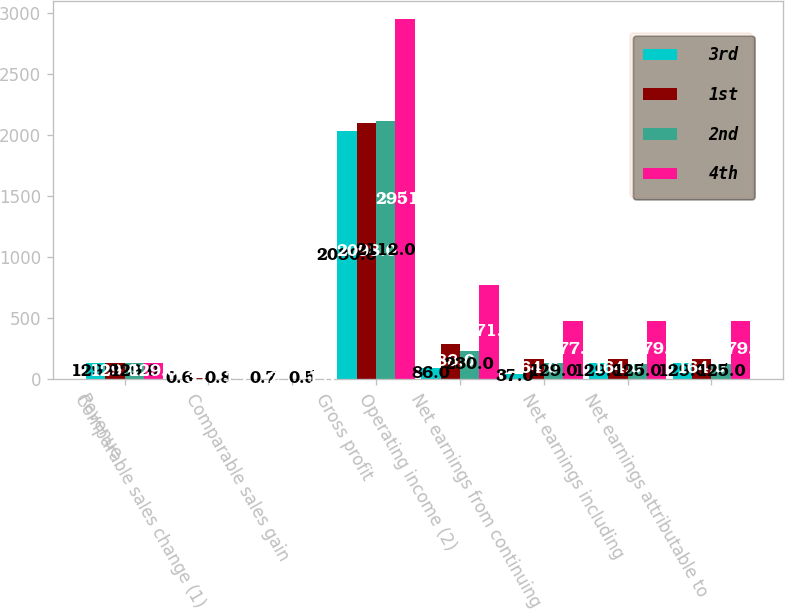Convert chart to OTSL. <chart><loc_0><loc_0><loc_500><loc_500><stacked_bar_chart><ecel><fcel>Revenue<fcel>Comparable sales change (1)<fcel>Comparable sales gain<fcel>Gross profit<fcel>Operating income (2)<fcel>Net earnings from continuing<fcel>Net earnings including<fcel>Net earnings attributable to<nl><fcel>3rd<fcel>129<fcel>0.6<fcel>0.7<fcel>2030<fcel>86<fcel>37<fcel>129<fcel>129<nl><fcel>1st<fcel>129<fcel>3.8<fcel>2.7<fcel>2098<fcel>288<fcel>164<fcel>164<fcel>164<nl><fcel>2nd<fcel>129<fcel>0.8<fcel>0.5<fcel>2112<fcel>230<fcel>129<fcel>125<fcel>125<nl><fcel>4th<fcel>129<fcel>1.7<fcel>1.8<fcel>2951<fcel>771<fcel>477<fcel>479<fcel>479<nl></chart> 